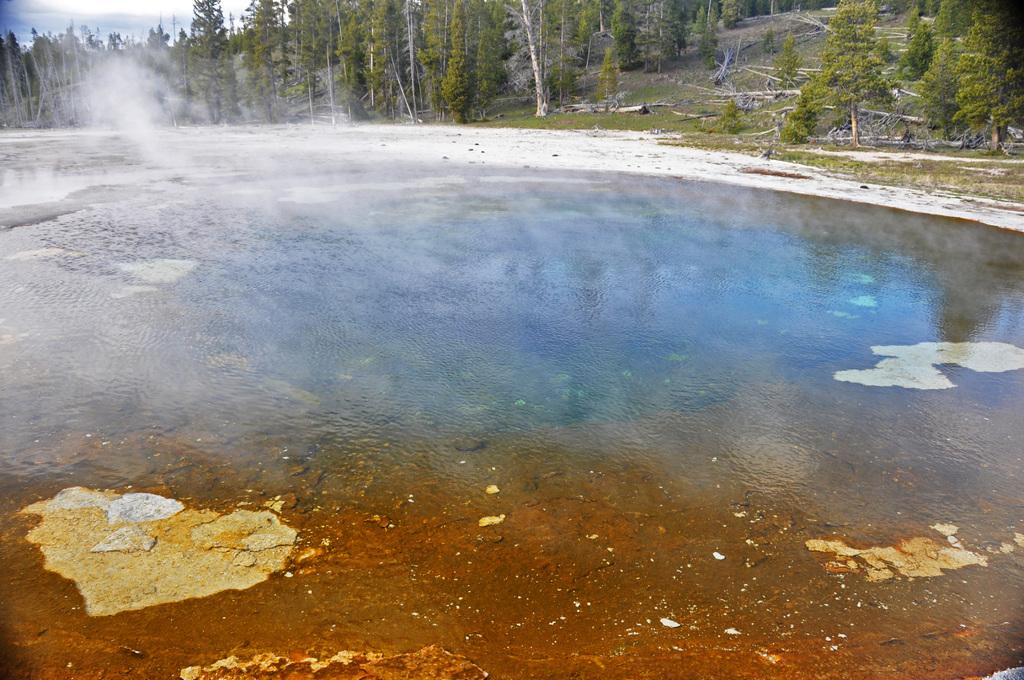What is the main subject in the center of the image? There is water in the center of the image. What can be seen in the background of the image? There are trees and grass in the background of the image. What is visible on the ground in the image? The ground is visible in the background of the image. What part of the sky is visible in the image? The sky is visible at the top left corner of the image. What type of yarn is being used to create the trees in the image? There is no yarn present in the image; the trees are depicted as natural vegetation. What month is it in the image? The image does not provide any information about the month or time of year. 